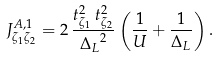<formula> <loc_0><loc_0><loc_500><loc_500>J ^ { A , 1 } _ { { \zeta } _ { 1 } { \zeta } _ { 2 } } = 2 \, \frac { t _ { { { \zeta } _ { 1 } } } ^ { 2 } \, t _ { { { \zeta } _ { 2 } } } ^ { 2 } } { { { \Delta } _ { L } } ^ { 2 } } \left ( \frac { 1 } { U } + \frac { 1 } { { \Delta } _ { L } } \right ) .</formula> 